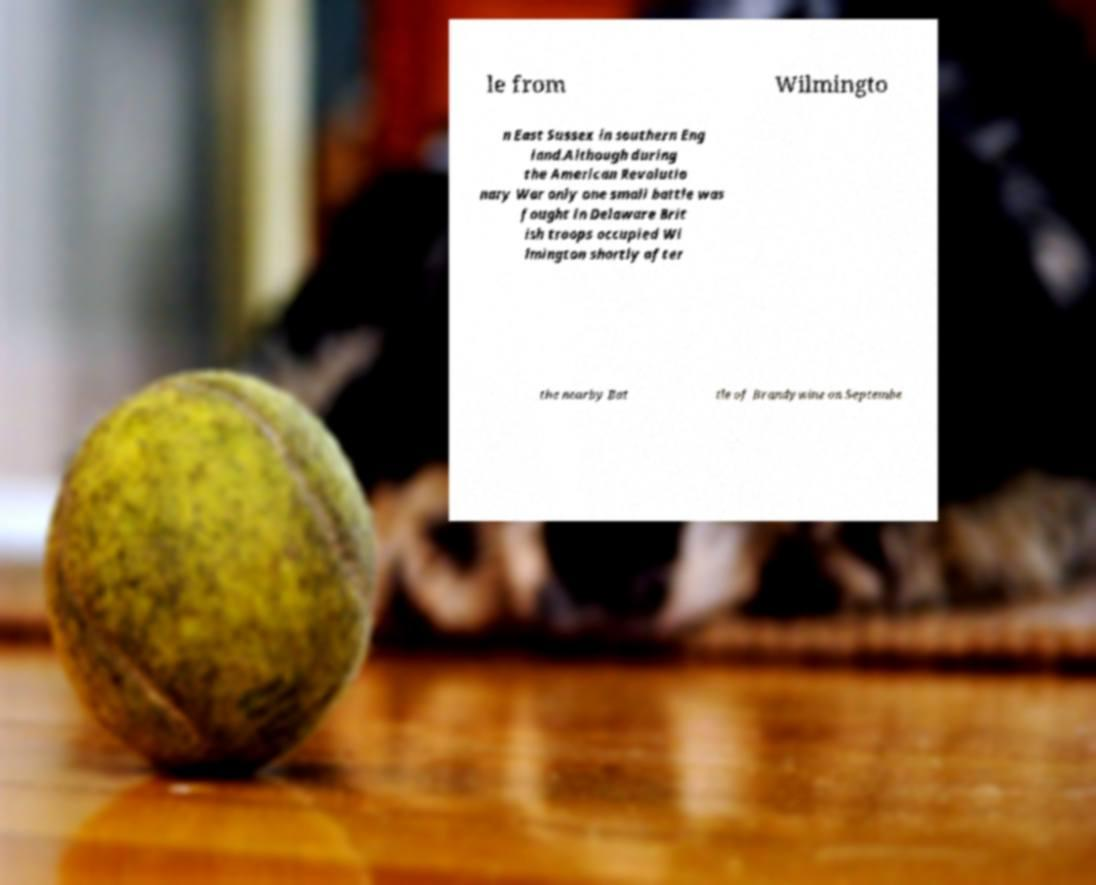I need the written content from this picture converted into text. Can you do that? le from Wilmingto n East Sussex in southern Eng land.Although during the American Revolutio nary War only one small battle was fought in Delaware Brit ish troops occupied Wi lmington shortly after the nearby Bat tle of Brandywine on Septembe 